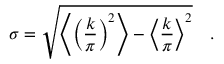<formula> <loc_0><loc_0><loc_500><loc_500>\sigma = \sqrt { \left \langle \left ( { \frac { k } { \pi } } \right ) ^ { 2 } \right \rangle - \left \langle { \frac { k } { \pi } } \right \rangle ^ { 2 } } \quad .</formula> 